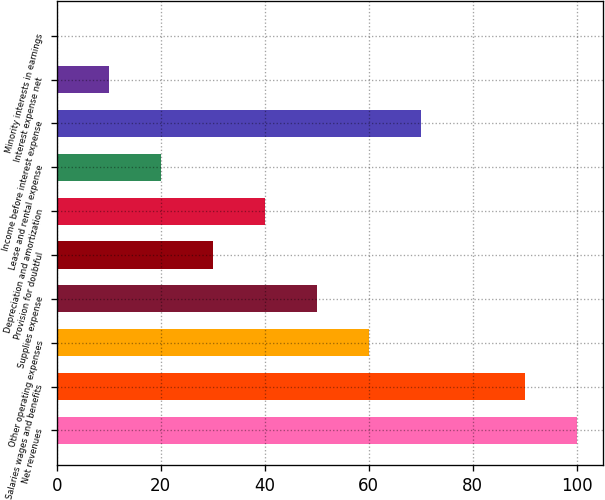Convert chart to OTSL. <chart><loc_0><loc_0><loc_500><loc_500><bar_chart><fcel>Net revenues<fcel>Salaries wages and benefits<fcel>Other operating expenses<fcel>Supplies expense<fcel>Provision for doubtful<fcel>Depreciation and amortization<fcel>Lease and rental expense<fcel>Income before interest expense<fcel>Interest expense net<fcel>Minority interests in earnings<nl><fcel>100<fcel>90.01<fcel>60.04<fcel>50.05<fcel>30.07<fcel>40.06<fcel>20.08<fcel>70.03<fcel>10.09<fcel>0.1<nl></chart> 